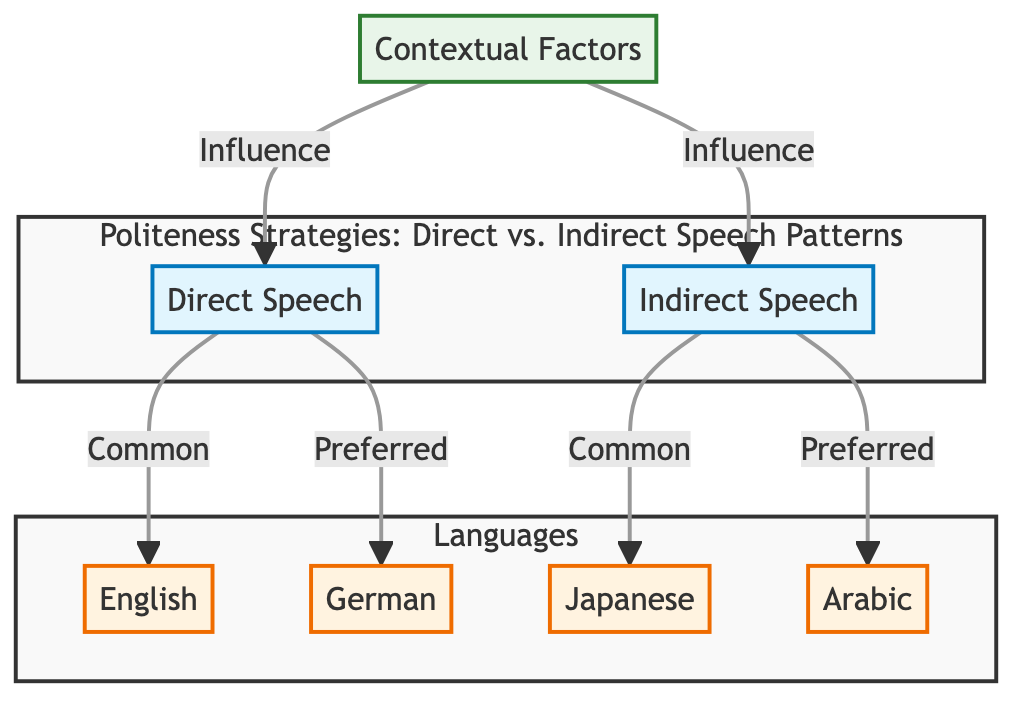What are the two main speech types shown in the diagram? The diagram highlights two primary types of speech: Direct Speech and Indirect Speech, represented by nodes labeled DS and IS respectively.
Answer: Direct Speech and Indirect Speech Which language shows Direct Speech as common? The diagram indicates that Direct Speech is common in English, denoted by the arrow connecting DS to EN with the label "Common."
Answer: English How many languages are represented in the diagram? There are four distinct languages depicted in the diagram: English, Japanese, German, and Arabic, which can be counted through the respective nodes.
Answer: Four Which speech type is preferred in German? The diagram illustrates that Direct Speech is preferred in German, conveyed by the connection from DS to DE with the label "Preferred."
Answer: Direct Speech Which speech type is common in Japanese? According to the diagram, Indirect Speech is common in Japanese, as shown by the connection from IS to JP with the label "Common."
Answer: Indirect Speech What contextual factor influences both Direct and Indirect Speech patterns? The diagram shows a node labeled Contextual Factors (CF) that has directed edges indicating an influence on both Direct and Indirect Speech, confirming that the influence pertains to contextual factors.
Answer: Contextual Factors Which speech pattern is shown as preferred in Arabic? The diagram clearly indicates through the arrow from IS to AR with the label "Preferred" that Indirect Speech is the preferred speech pattern in Arabic.
Answer: Indirect Speech What does the arrow between Direct Speech and English represent? The arrow with the label "Common" between Direct Speech (DS) and English (EN) represents the relationship that indicates Direct Speech is commonly used in the English language.
Answer: Common How do Direct and Indirect Speech interact in the diagram? The diagram presents that Direct Speech primarily links to English and German, while Indirect Speech connects to Japanese and Arabic, suggesting a contrast in usage patterns across cultures.
Answer: They interact by representing different preferences across languages 